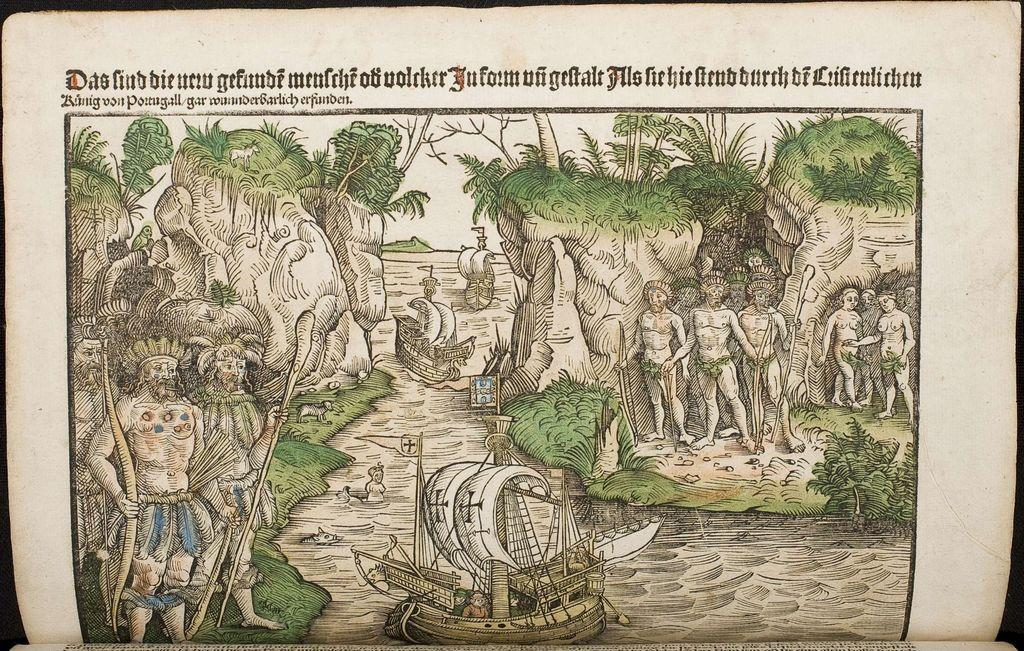What is depicted on the paper in the image? The paper contains many persons and trees. What can be seen in the middle of the image? There is water in the middle of the image. What is floating on the water in the image? Boats are present in the water. What is written at the top of the image? There is text at the top of the image. How many roses are floating in the water in the image? There are no roses present in the image; it features water and boats. What type of debt is being discussed in the image? There is no mention of debt in the image; it contains a paper with many persons and trees, water, boats, and text. 